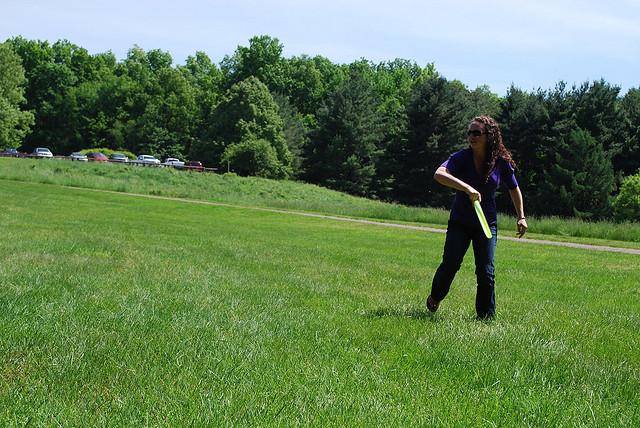What color is the frisbee?
Keep it brief. Green. How many people are wearing hats?
Answer briefly. 0. Can a flying Frisbee break a window?
Be succinct. Yes. Is the girls hair short?
Be succinct. No. What is the lady holding?
Answer briefly. Frisbee. Has the frisbee been released?
Quick response, please. No. Is this woman indoors?
Give a very brief answer. No. 